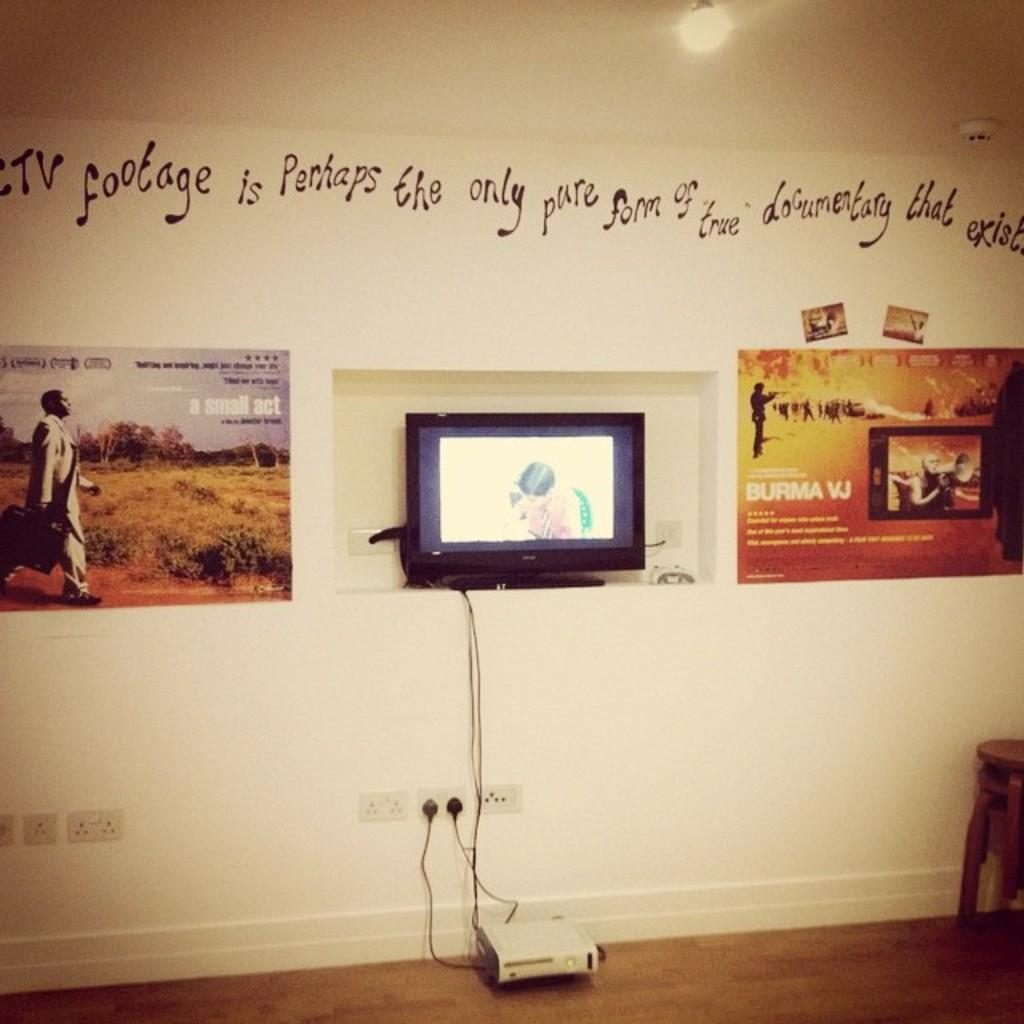<image>
Share a concise interpretation of the image provided. The sign on the wall claims that footage is the only pure form of documentary. 